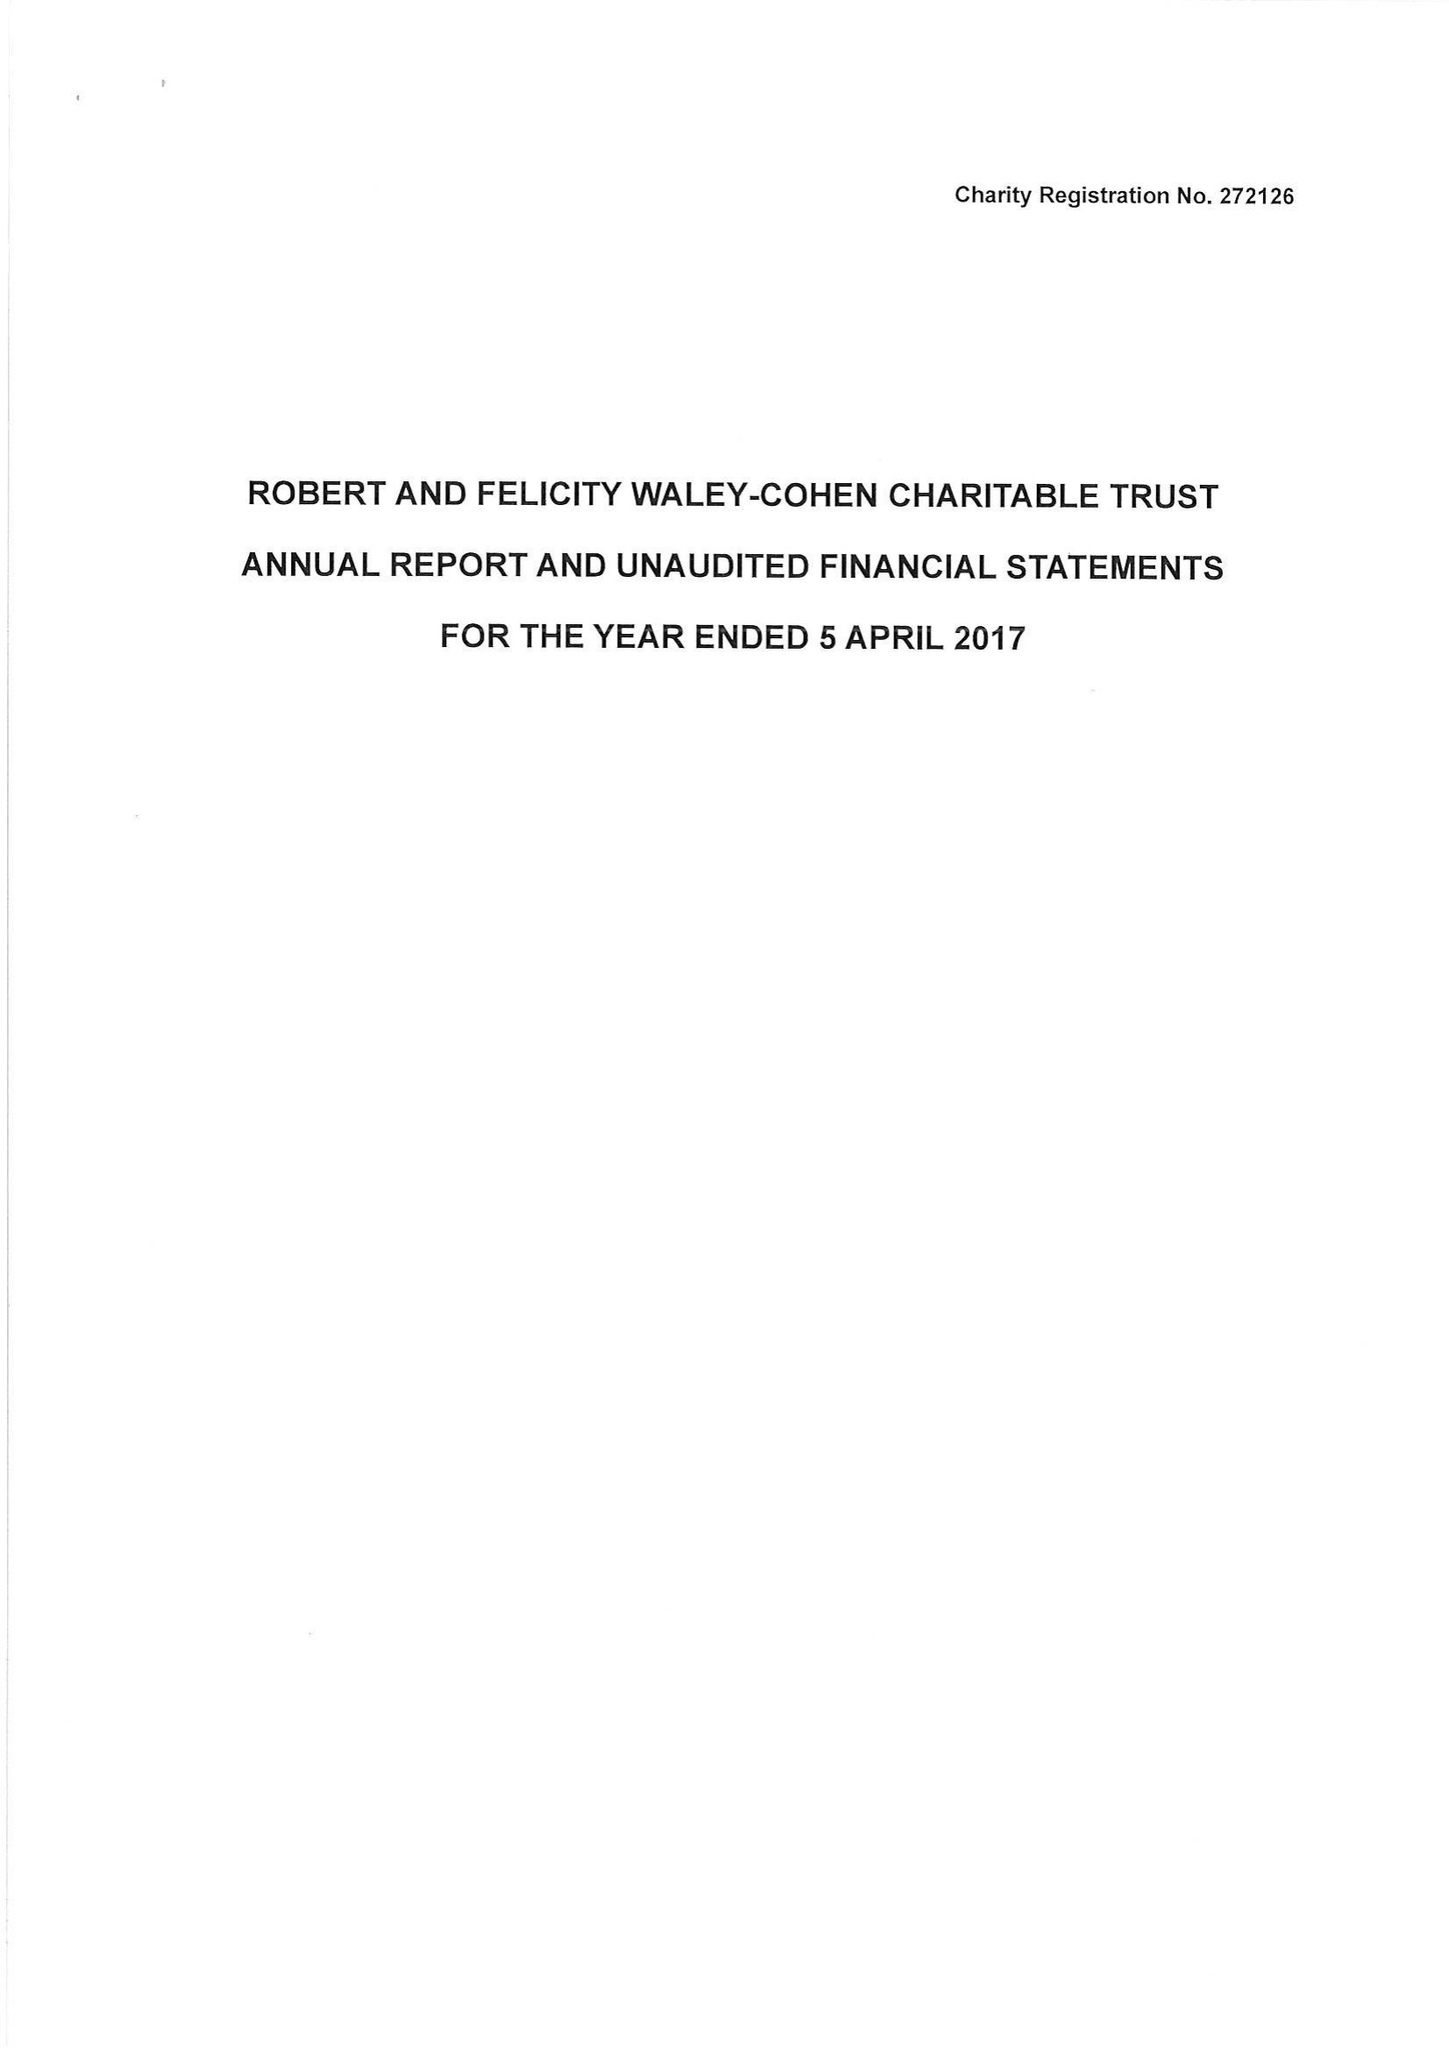What is the value for the charity_name?
Answer the question using a single word or phrase. Robert and Felicity Waley-Cohen Charitable Trust 